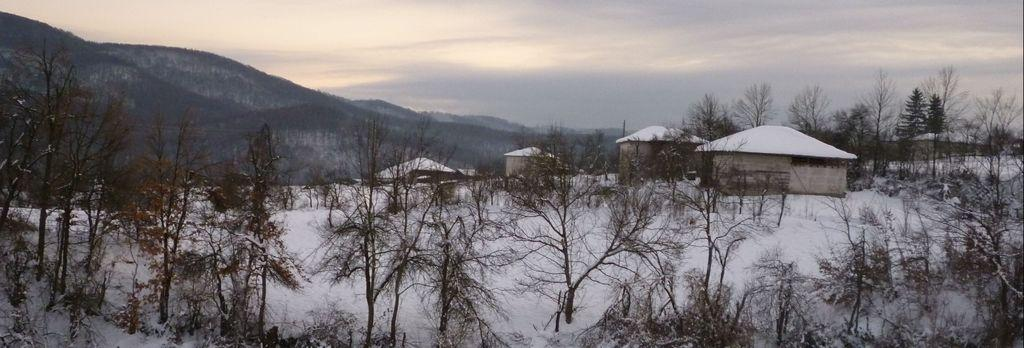What type of vegetation can be seen in the image? There are trees in the image. What type of structures are present in the image? There are huts in the image. What is the ground covered with in the image? There is snow visible in the image. What can be seen in the background of the image? There are hills in the background of the image. What is visible in the sky in the image? The sky is visible in the image, and clouds are present. Can you tell me how many rats are hiding under the huts in the image? There are no rats present in the image; it features trees, huts, snow, hills, and a sky with clouds. What type of prose is written on the trees in the image? There is no prose written on the trees in the image; it is a natural scene with trees, huts, snow, hills, and a sky with clouds. 